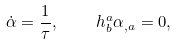Convert formula to latex. <formula><loc_0><loc_0><loc_500><loc_500>\dot { \alpha } = \frac { 1 } { \tau } , \quad h ^ { a } _ { b } \alpha _ { , a } = 0 ,</formula> 